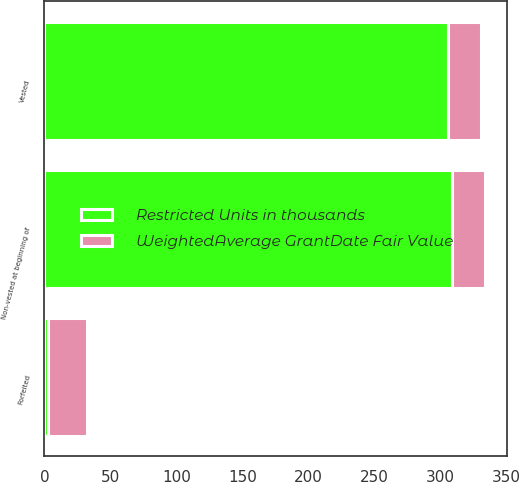Convert chart. <chart><loc_0><loc_0><loc_500><loc_500><stacked_bar_chart><ecel><fcel>Non-vested at beginning of<fcel>Vested<fcel>Forfeited<nl><fcel>Restricted Units in thousands<fcel>309<fcel>306<fcel>3<nl><fcel>WeightedAverage GrantDate Fair Value<fcel>25.08<fcel>25.04<fcel>28.99<nl></chart> 